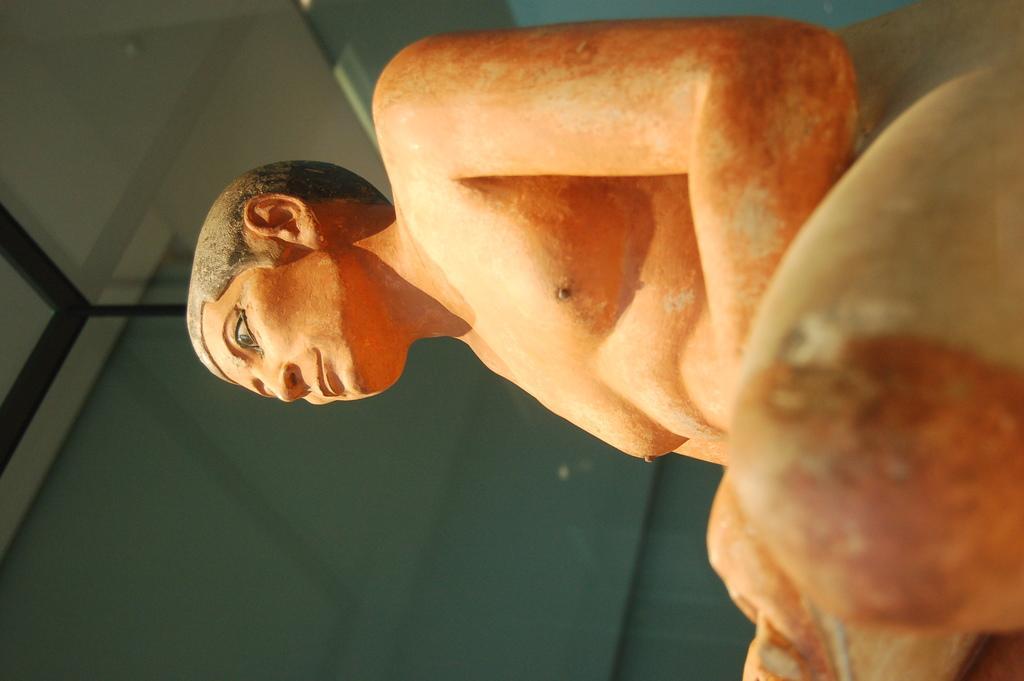Please provide a concise description of this image. In this image I can see sculpture of a man. I can see colour of this sculpture is orange. 